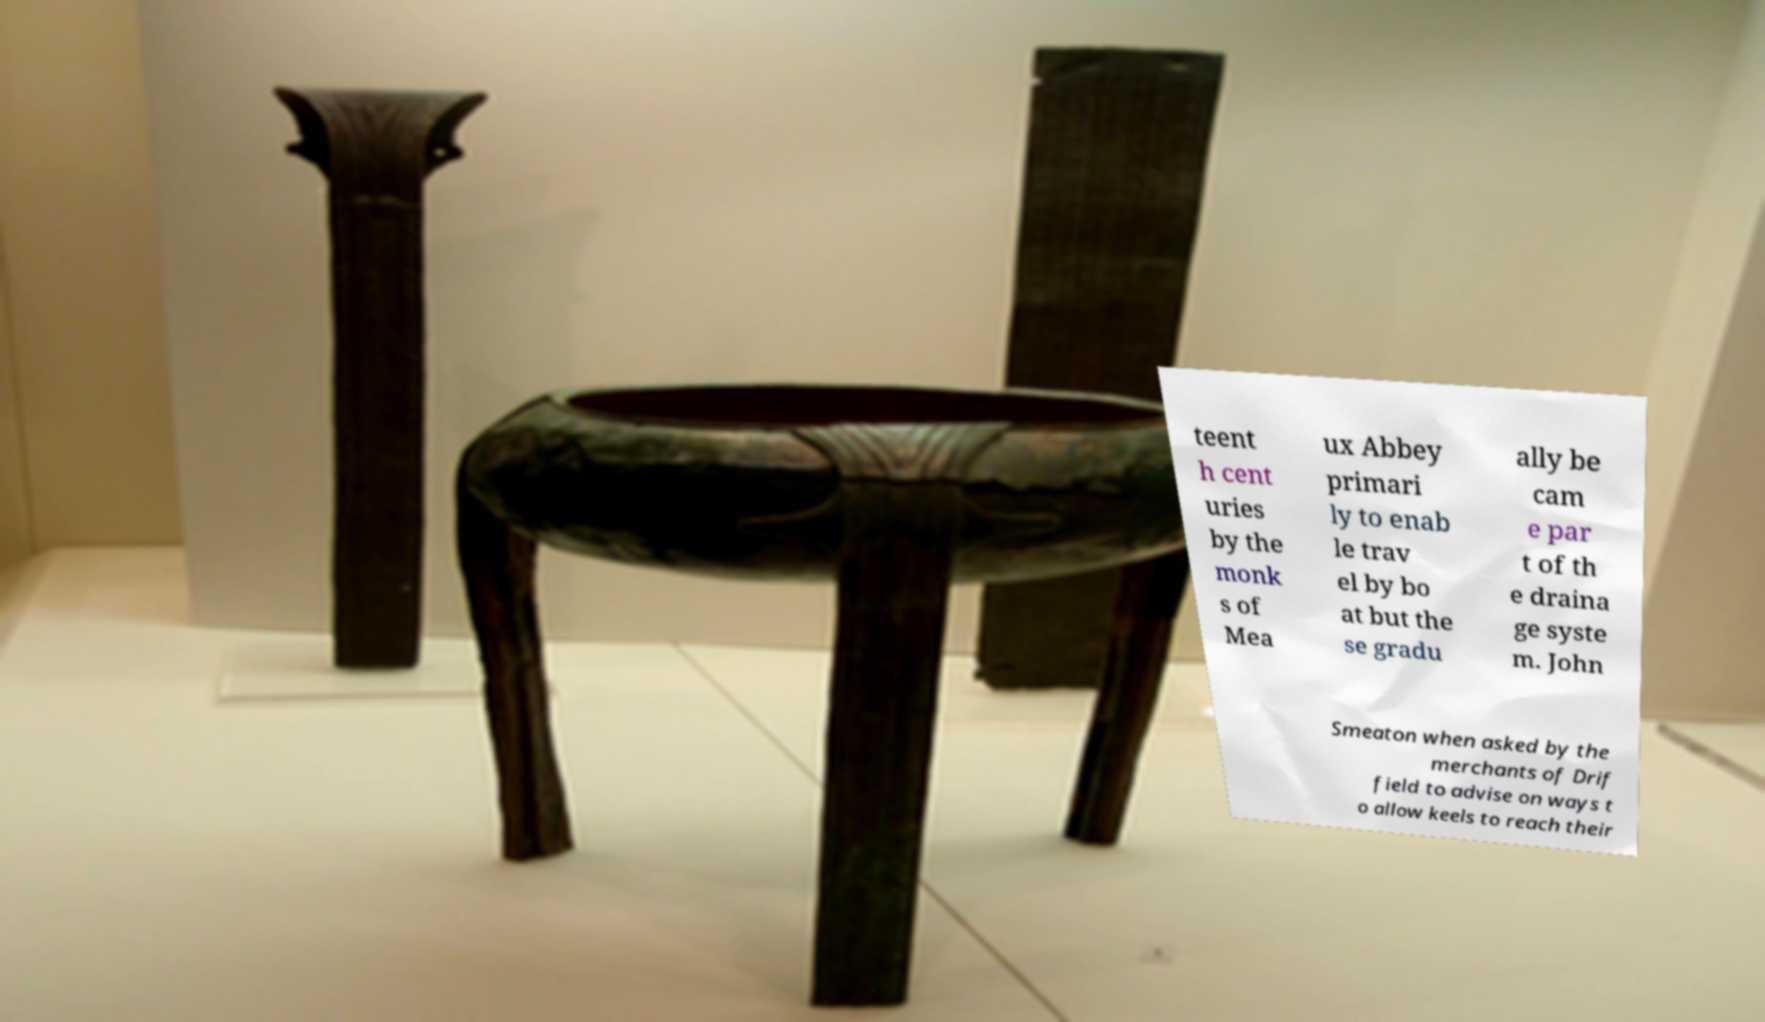There's text embedded in this image that I need extracted. Can you transcribe it verbatim? teent h cent uries by the monk s of Mea ux Abbey primari ly to enab le trav el by bo at but the se gradu ally be cam e par t of th e draina ge syste m. John Smeaton when asked by the merchants of Drif field to advise on ways t o allow keels to reach their 